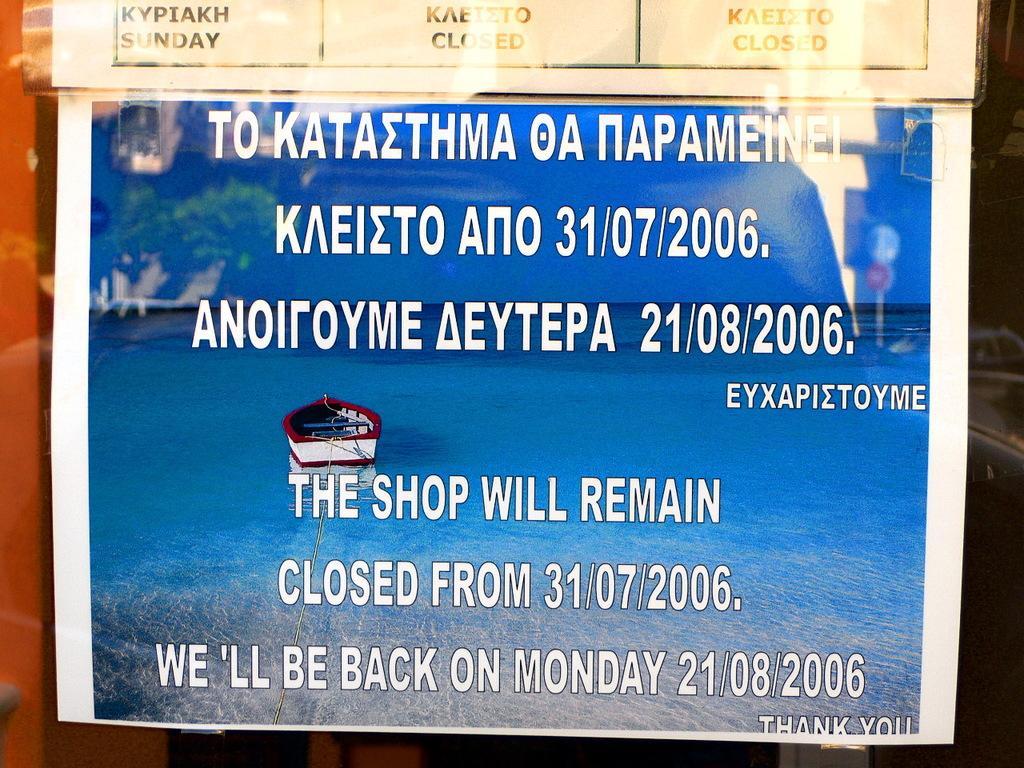Can you describe this image briefly? In this image I can see a pomp let , on the pomp let I can see text ,image of boat, sea and text 